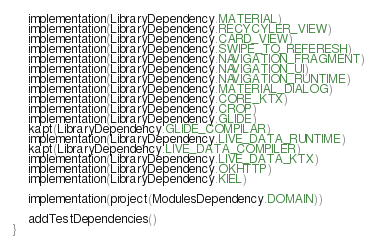Convert code to text. <code><loc_0><loc_0><loc_500><loc_500><_Kotlin_>    implementation(LibraryDependency.MATERIAL)
    implementation(LibraryDependency.RECYCYLER_VIEW)
    implementation(LibraryDependency.CARD_VIEW)
    implementation(LibraryDependency.SWIPE_TO_REFERESH)
    implementation(LibraryDependency.NAVIGATION_FRAGMENT)
    implementation(LibraryDependency.NAVIGATION_UI)
    implementation(LibraryDependency.NAVIGATION_RUNTIME)
    implementation(LibraryDependency.MATERIAL_DIALOG)
    implementation(LibraryDependency.CORE_KTX)
    implementation(LibraryDependency.CROP)
    implementation(LibraryDependency.GLIDE)
    kapt(LibraryDependency.GLIDE_COMPILAR)
    implementation(LibraryDependency.LIVE_DATA_RUNTIME)
    kapt(LibraryDependency.LIVE_DATA_COMPILER)
    implementation(LibraryDependency.LIVE_DATA_KTX)
    implementation(LibraryDependency.OKHTTP)
    implementation(LibraryDependency.KIEL)

    implementation(project(ModulesDependency.DOMAIN))

    addTestDependencies()
}
</code> 